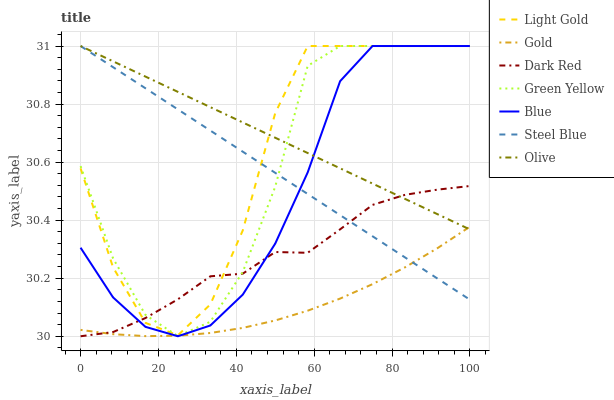Does Gold have the minimum area under the curve?
Answer yes or no. Yes. Does Olive have the maximum area under the curve?
Answer yes or no. Yes. Does Dark Red have the minimum area under the curve?
Answer yes or no. No. Does Dark Red have the maximum area under the curve?
Answer yes or no. No. Is Olive the smoothest?
Answer yes or no. Yes. Is Green Yellow the roughest?
Answer yes or no. Yes. Is Gold the smoothest?
Answer yes or no. No. Is Gold the roughest?
Answer yes or no. No. Does Dark Red have the lowest value?
Answer yes or no. Yes. Does Gold have the lowest value?
Answer yes or no. No. Does Light Gold have the highest value?
Answer yes or no. Yes. Does Dark Red have the highest value?
Answer yes or no. No. Is Gold less than Light Gold?
Answer yes or no. Yes. Is Light Gold greater than Gold?
Answer yes or no. Yes. Does Light Gold intersect Steel Blue?
Answer yes or no. Yes. Is Light Gold less than Steel Blue?
Answer yes or no. No. Is Light Gold greater than Steel Blue?
Answer yes or no. No. Does Gold intersect Light Gold?
Answer yes or no. No. 